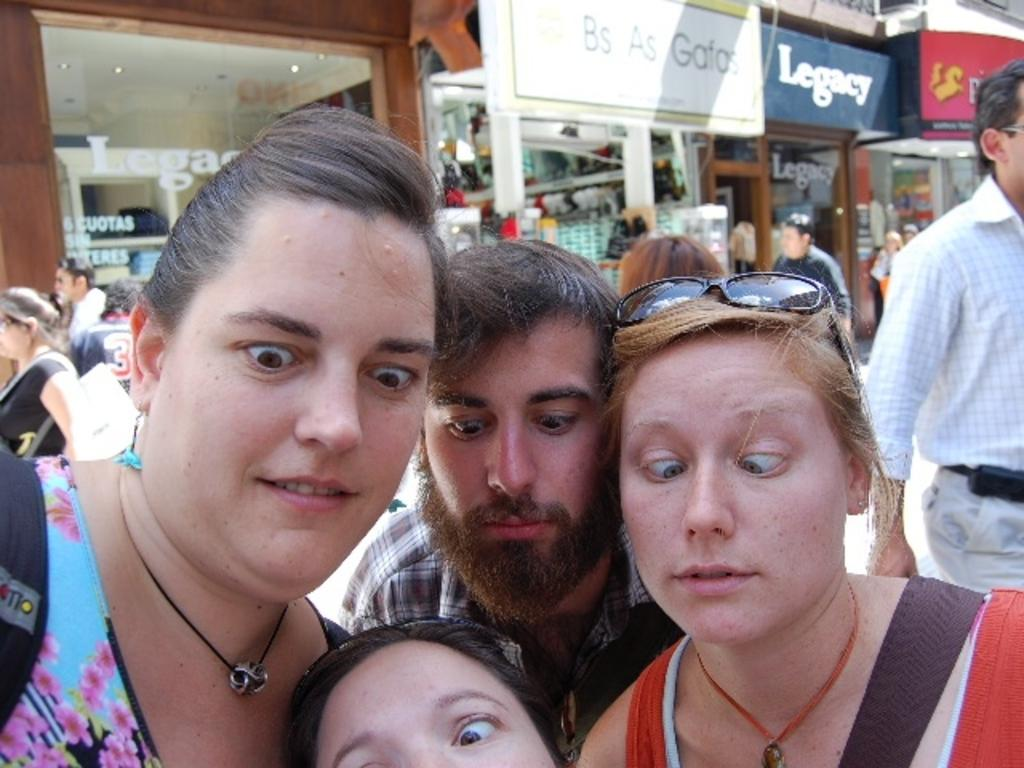Who or what can be seen in the image? There are people in the image. What can be seen in the background of the image? There are boards, stores, and other unspecified objects in the background of the image. What type of plantation can be seen in the image? There is no plantation present in the image. How does the image attempt to convey a specific message? The image does not attempt to convey a specific message; it simply shows people and objects in a particular setting. 